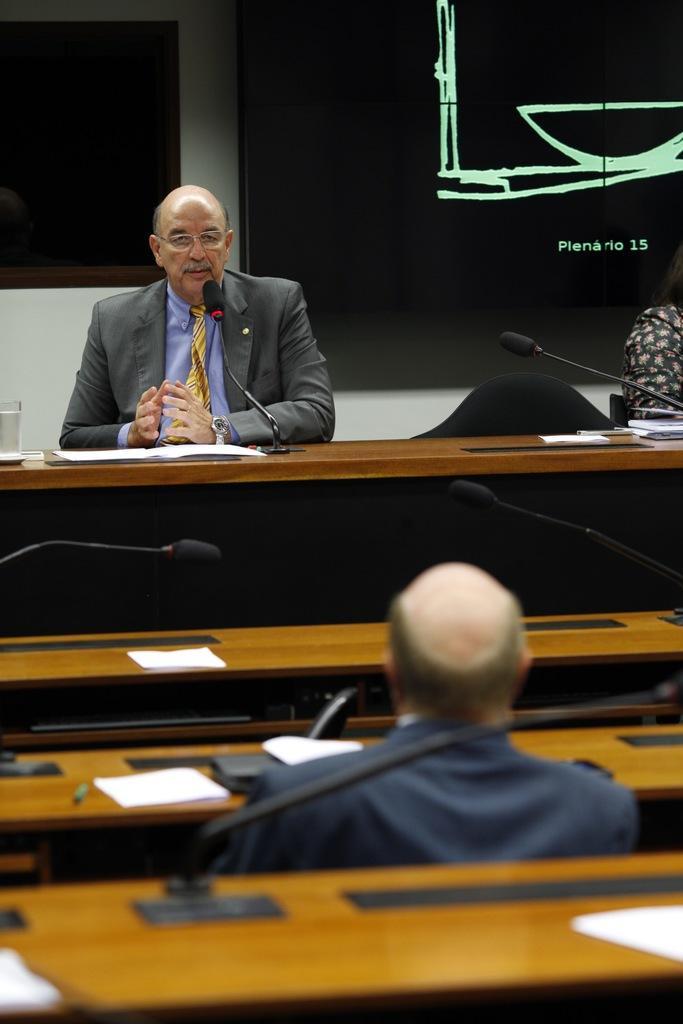Please provide a concise description of this image. In this image in the center there is one person who is sitting, and he is talking in front of him there is a mike and table. On the table there are some papers and glass and also there are some tables. At the bottom and one person is sitting, on the tables there are some papers mikes and pens, and in the background there is a television and a screen and wall. On the right side there is another person. 